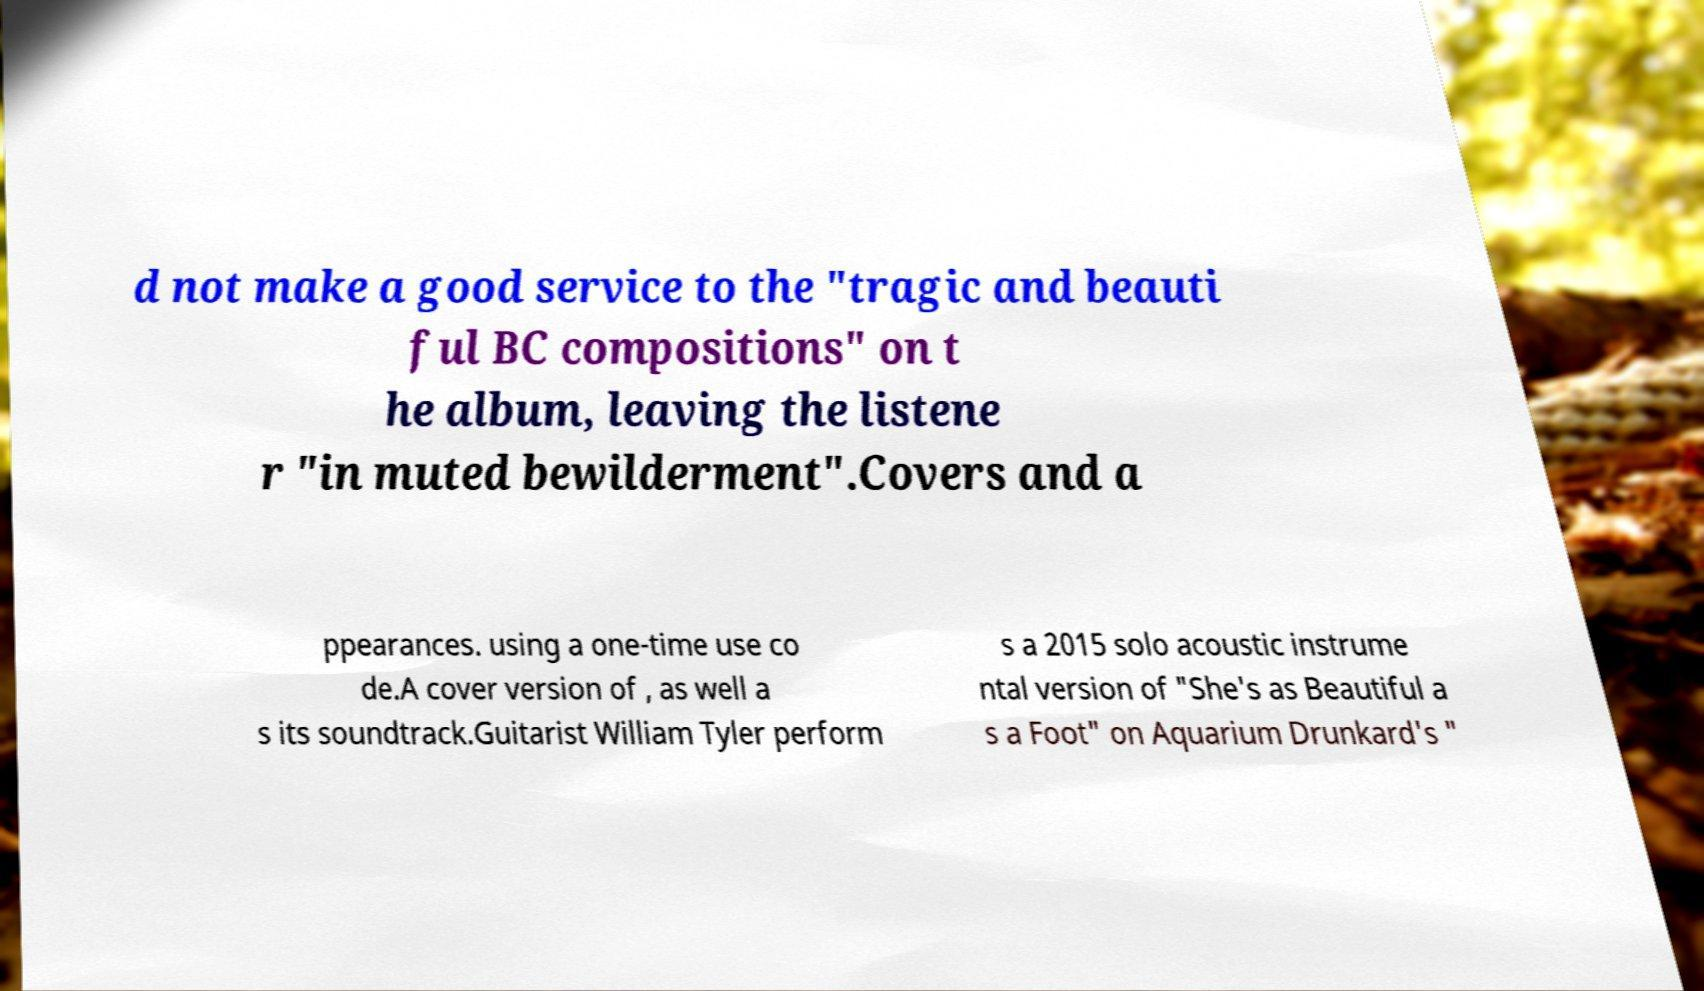Could you assist in decoding the text presented in this image and type it out clearly? d not make a good service to the "tragic and beauti ful BC compositions" on t he album, leaving the listene r "in muted bewilderment".Covers and a ppearances. using a one-time use co de.A cover version of , as well a s its soundtrack.Guitarist William Tyler perform s a 2015 solo acoustic instrume ntal version of "She's as Beautiful a s a Foot" on Aquarium Drunkard's " 